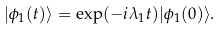Convert formula to latex. <formula><loc_0><loc_0><loc_500><loc_500>| \phi _ { 1 } ( t ) \rangle = \exp ( - i \lambda _ { 1 } t ) | \phi _ { 1 } ( 0 ) \rangle .</formula> 